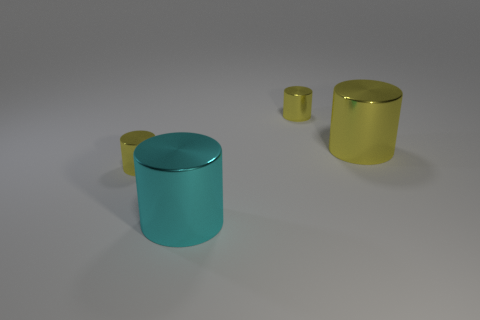Subtract all cyan cylinders. How many cylinders are left? 3 Add 3 cyan shiny things. How many objects exist? 7 Subtract all cyan cylinders. How many cylinders are left? 3 Add 4 small yellow shiny cylinders. How many small yellow shiny cylinders exist? 6 Subtract 0 yellow balls. How many objects are left? 4 Subtract 2 cylinders. How many cylinders are left? 2 Subtract all purple cylinders. Subtract all red spheres. How many cylinders are left? 4 Subtract all brown spheres. How many brown cylinders are left? 0 Subtract all small green matte cylinders. Subtract all small yellow metal objects. How many objects are left? 2 Add 1 small cylinders. How many small cylinders are left? 3 